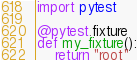<code> <loc_0><loc_0><loc_500><loc_500><_Python_>import pytest

@pytest.fixture
def my_fixture():
	return "root"</code> 